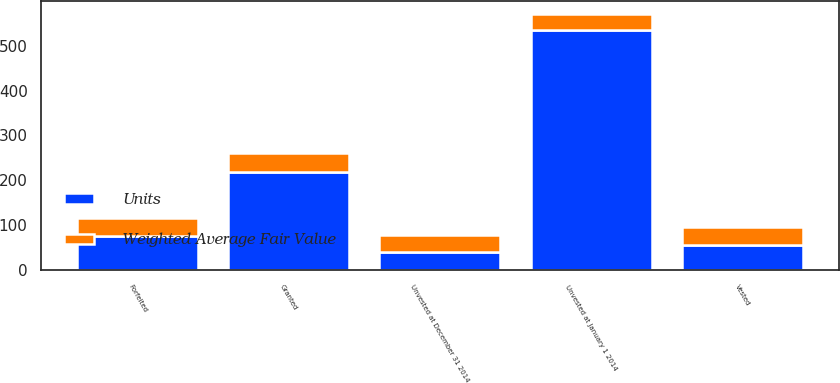<chart> <loc_0><loc_0><loc_500><loc_500><stacked_bar_chart><ecel><fcel>Unvested at January 1 2014<fcel>Granted<fcel>Vested<fcel>Forfeited<fcel>Unvested at December 31 2014<nl><fcel>Units<fcel>535<fcel>219<fcel>57<fcel>77<fcel>41.41<nl><fcel>Weighted Average Fair Value<fcel>35.68<fcel>41.41<fcel>39.58<fcel>38.41<fcel>37.44<nl></chart> 